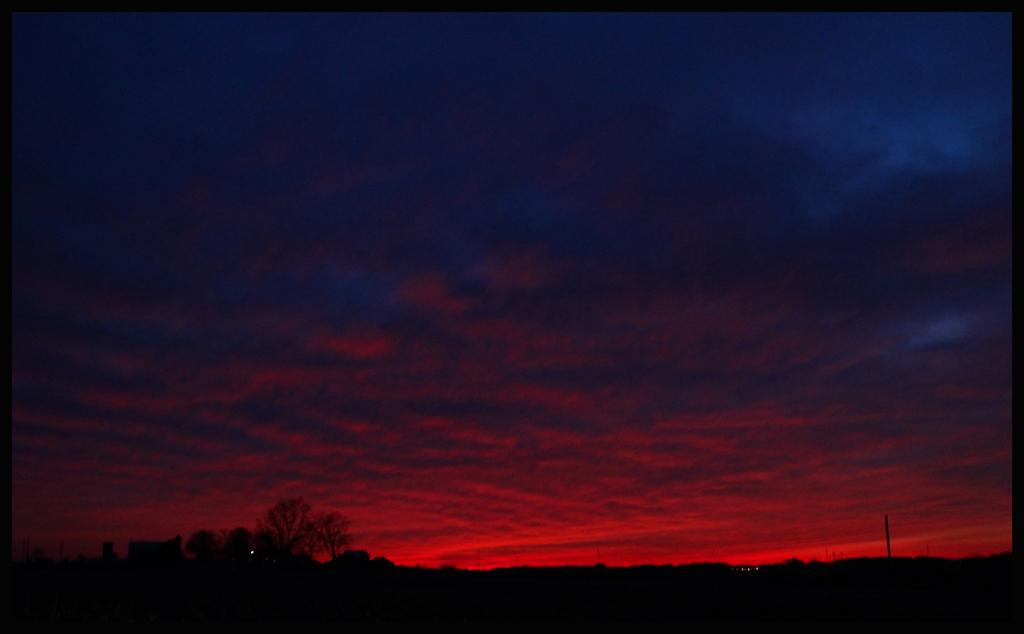What type of vegetation can be seen in the image? There are trees in the image. What part of the natural environment is visible in the image? The sky is visible in the image. What colors can be seen in the sky? The sky has red and blue colors. What type of insurance policy is being discussed by the visitor in the image? There is no visitor present in the image, and therefore no discussion about insurance policies. How is the hose being used in the image? There is no hose present in the image. 